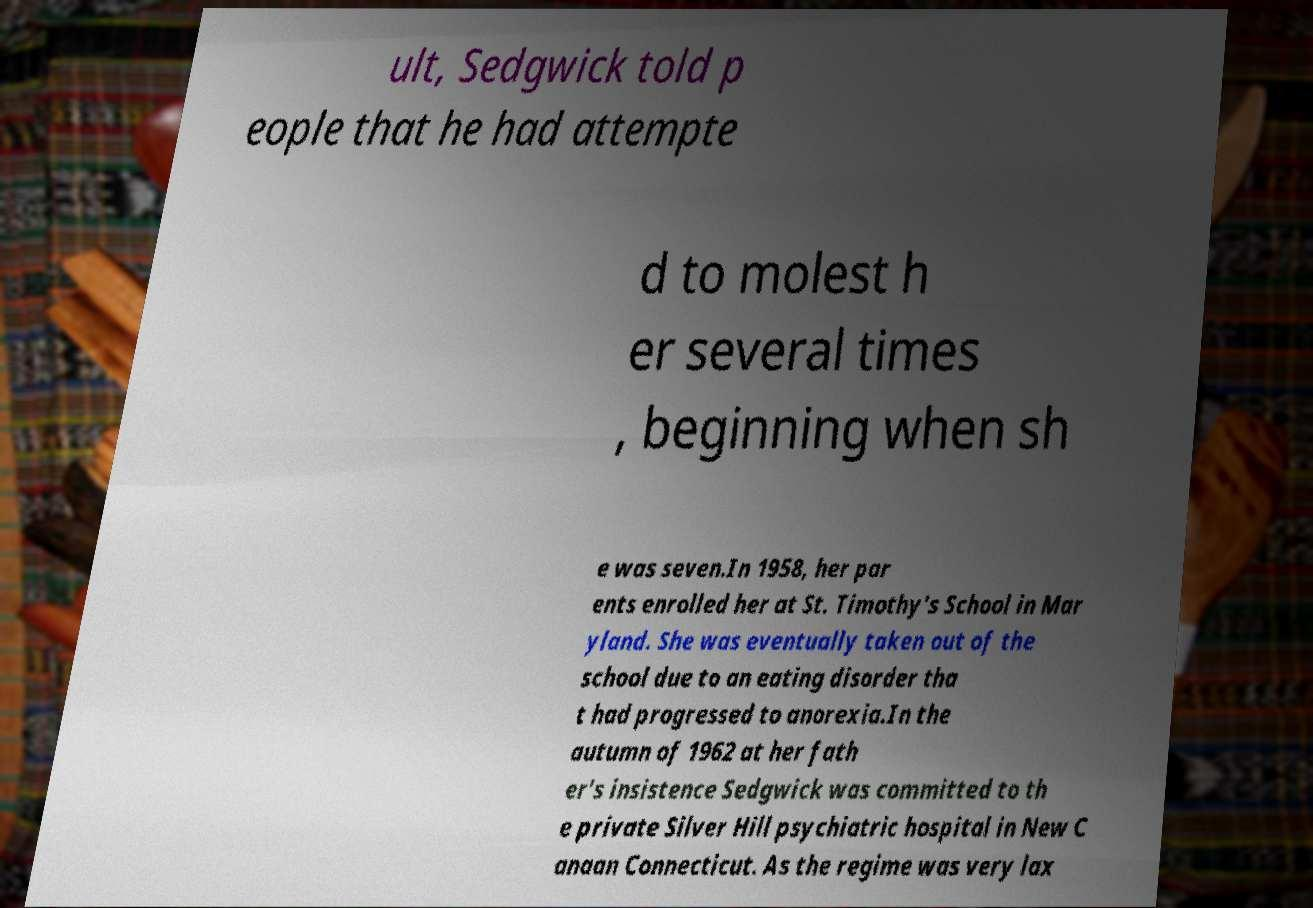Can you accurately transcribe the text from the provided image for me? ult, Sedgwick told p eople that he had attempte d to molest h er several times , beginning when sh e was seven.In 1958, her par ents enrolled her at St. Timothy's School in Mar yland. She was eventually taken out of the school due to an eating disorder tha t had progressed to anorexia.In the autumn of 1962 at her fath er's insistence Sedgwick was committed to th e private Silver Hill psychiatric hospital in New C anaan Connecticut. As the regime was very lax 